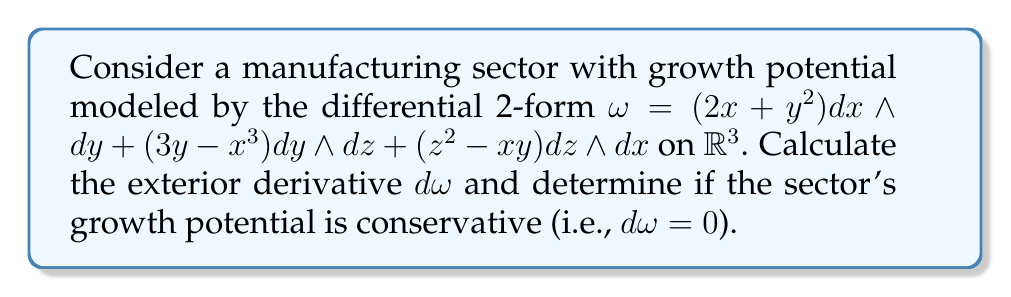Give your solution to this math problem. To solve this problem, we need to calculate the exterior derivative of the given 2-form $\omega$. Let's break it down step-by-step:

1) The general form of a 2-form in $\mathbb{R}^3$ is:
   $\omega = f(x,y,z) dx \wedge dy + g(x,y,z) dy \wedge dz + h(x,y,z) dz \wedge dx$

   In our case:
   $f(x,y,z) = 2x + y^2$
   $g(x,y,z) = 3y - x^3$
   $h(x,y,z) = z^2 - xy$

2) The exterior derivative of a 2-form in $\mathbb{R}^3$ is given by:
   $d\omega = (\frac{\partial f}{\partial z} + \frac{\partial g}{\partial x} + \frac{\partial h}{\partial y}) dx \wedge dy \wedge dz$

3) Let's calculate each partial derivative:

   $\frac{\partial f}{\partial z} = 0$

   $\frac{\partial g}{\partial x} = -3x^2$

   $\frac{\partial h}{\partial y} = -x$

4) Now, we can substitute these values into the formula for $d\omega$:

   $d\omega = (0 + (-3x^2) + (-x)) dx \wedge dy \wedge dz$
   
   $d\omega = (-3x^2 - x) dx \wedge dy \wedge dz$

5) Since $d\omega \neq 0$, the sector's growth potential is not conservative.
Answer: $d\omega = (-3x^2 - x) dx \wedge dy \wedge dz$; Not conservative 